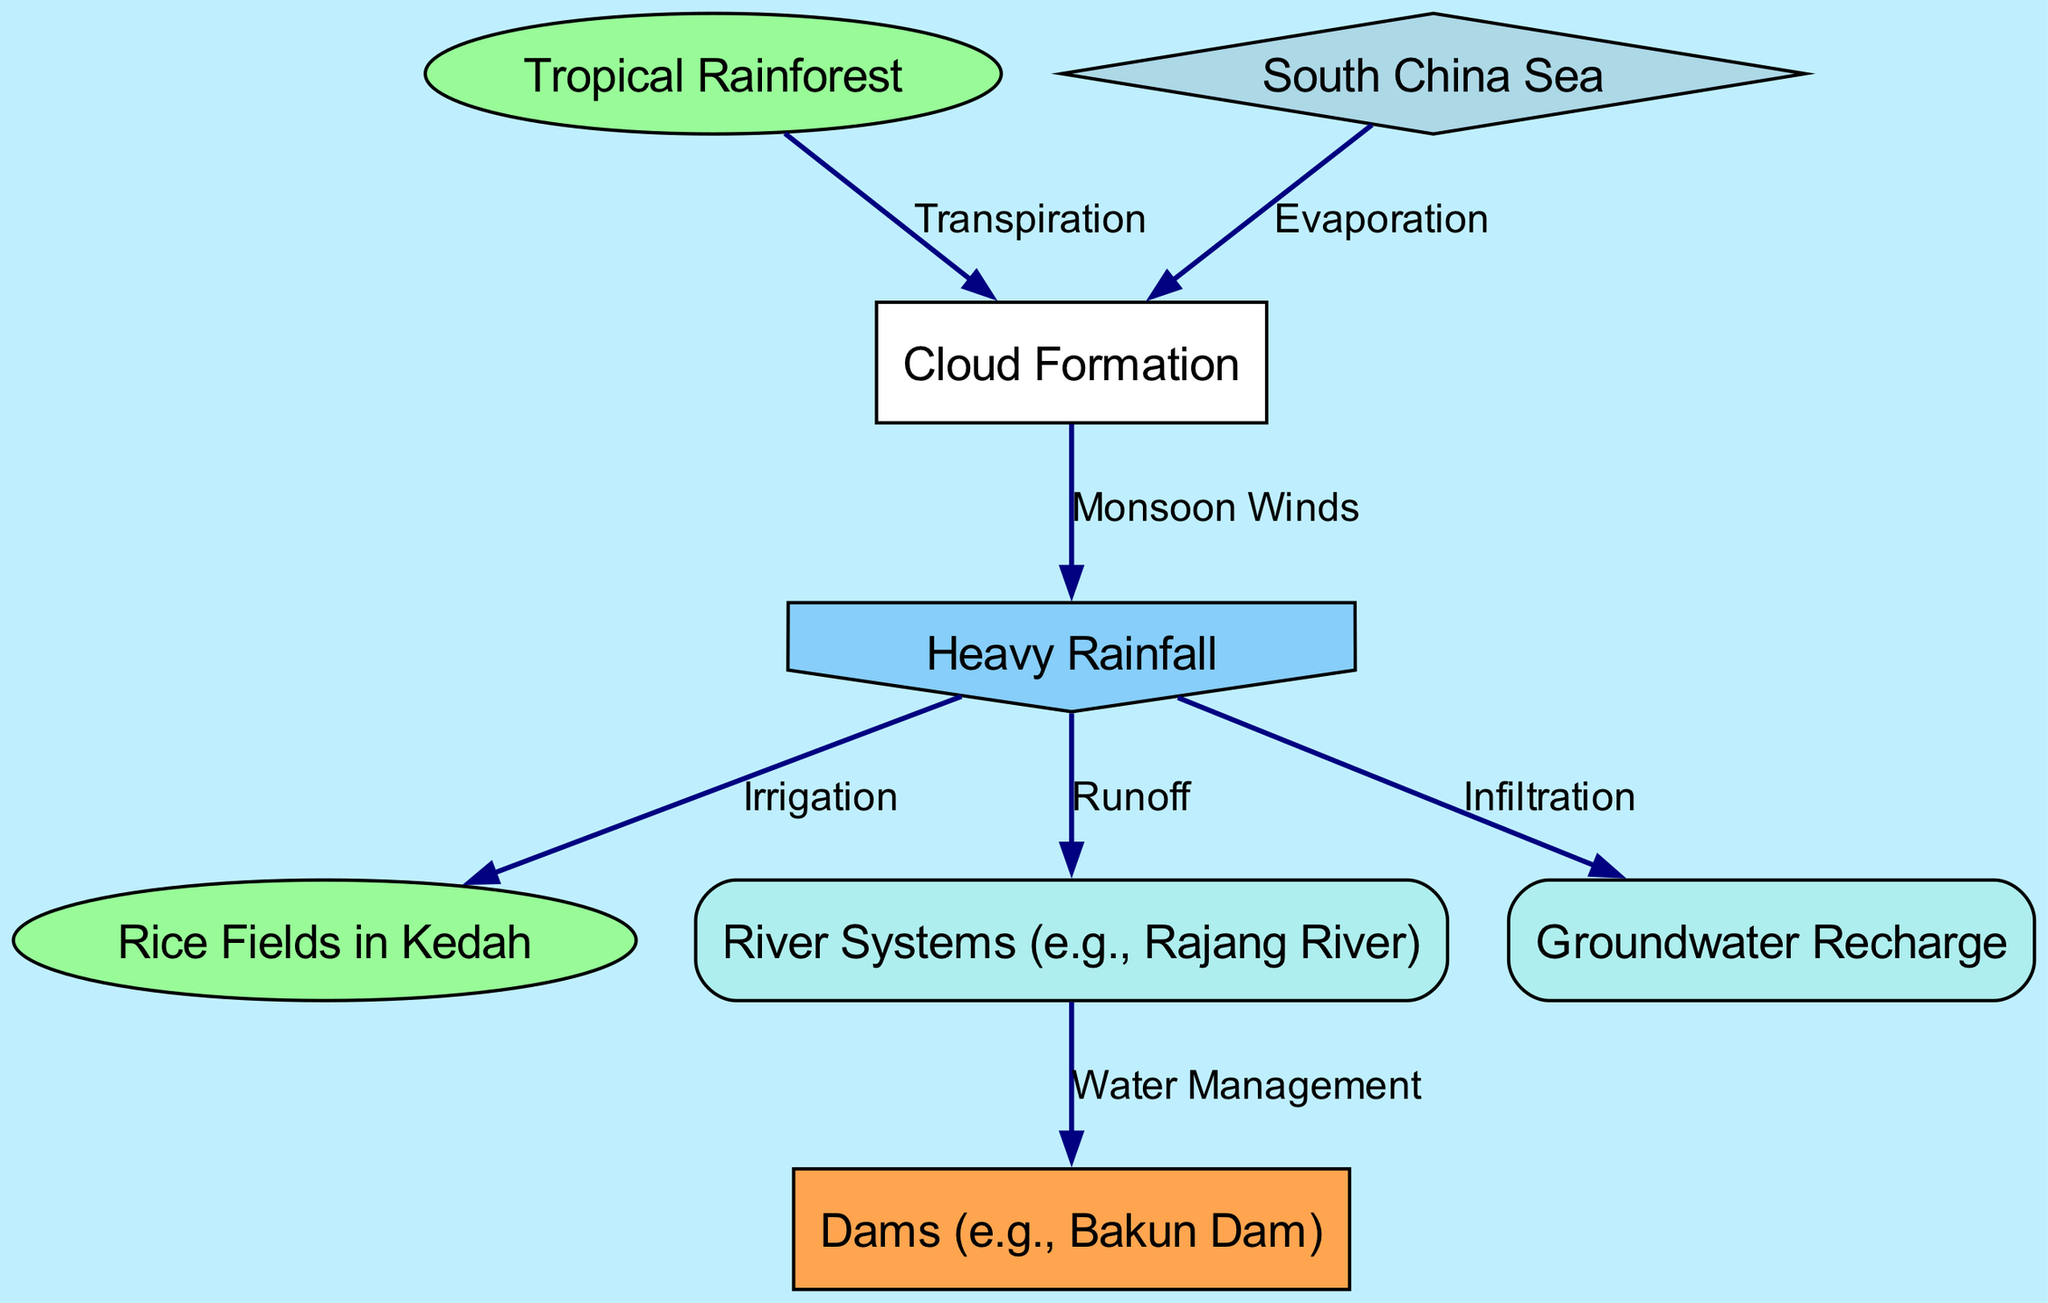What is the total number of nodes in this diagram? The nodes in the diagram include Tropical Rainforest, South China Sea, Cloud Formation, Heavy Rainfall, Rice Fields in Kedah, River Systems, Groundwater Recharge, and Dams. Counting these gives a total of 8 nodes.
Answer: 8 What is the primary relationship depicted between the South China Sea and Cloud Formation? The diagram shows that South China Sea leads to Cloud Formation through the process of Evaporation, indicating that water vapor rises from the sea.
Answer: Evaporation What process connects Heavy Rainfall to Rice Fields in Kedah? Heavy Rainfall is connected to Rice Fields in Kedah by the process of Irrigation, which helps supply water for rice cultivation during wet conditions.
Answer: Irrigation Which node indicates water storage for management purposes? The node labeled Dams (e.g., Bakun Dam) shows how water is stored and managed, utilizing the input from River Systems.
Answer: Dams How does Heavy Rainfall affect Groundwater Recharge? According to the diagram, Heavy Rainfall leads to Groundwater Recharge through the process of Infiltration, where excess water seeps into the ground.
Answer: Infiltration What role does Tropical Rainforest play in the water cycle? Tropical Rainforest contributes to the water cycle through the process of Transpiration, where plants release water vapor into the atmosphere.
Answer: Transpiration How does Heavy Rainfall relate to River Systems? Heavy Rainfall results in Runoff, which directly flows into and affects River Systems, indicating that more rainfall leads to increased water in the rivers.
Answer: Runoff What natural feature is a source of moisture for Cloud Formation besides the South China Sea? Besides the South China Sea, the Tropical Rainforest also serves as a source of moisture for Cloud Formation through Transpiration.
Answer: Tropical Rainforest 